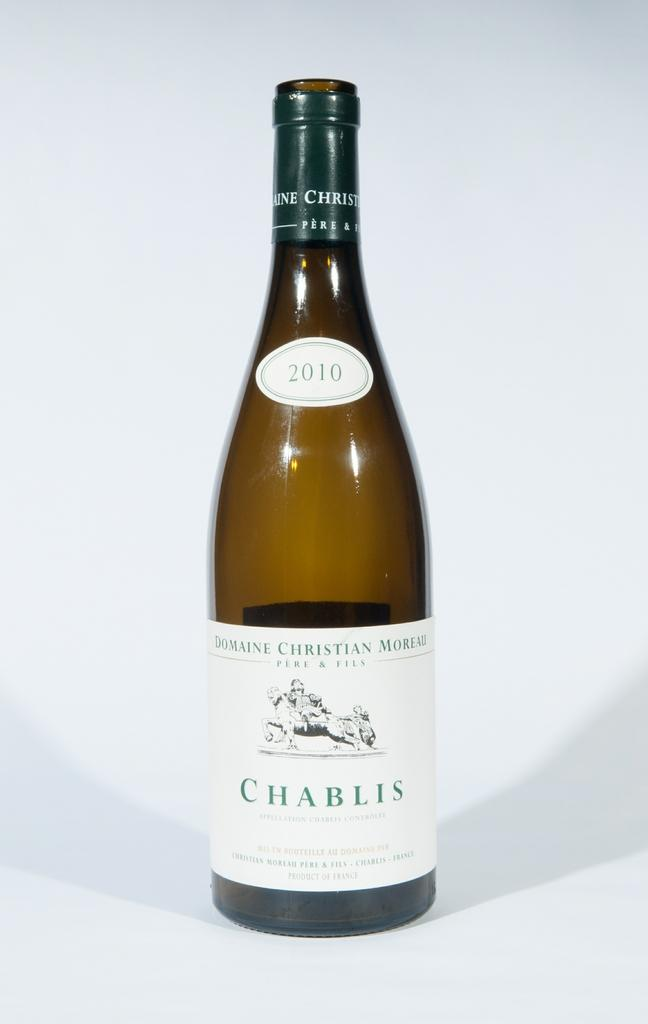<image>
Offer a succinct explanation of the picture presented. A wine bottle from 2010 named Chablis in front of a white background. 